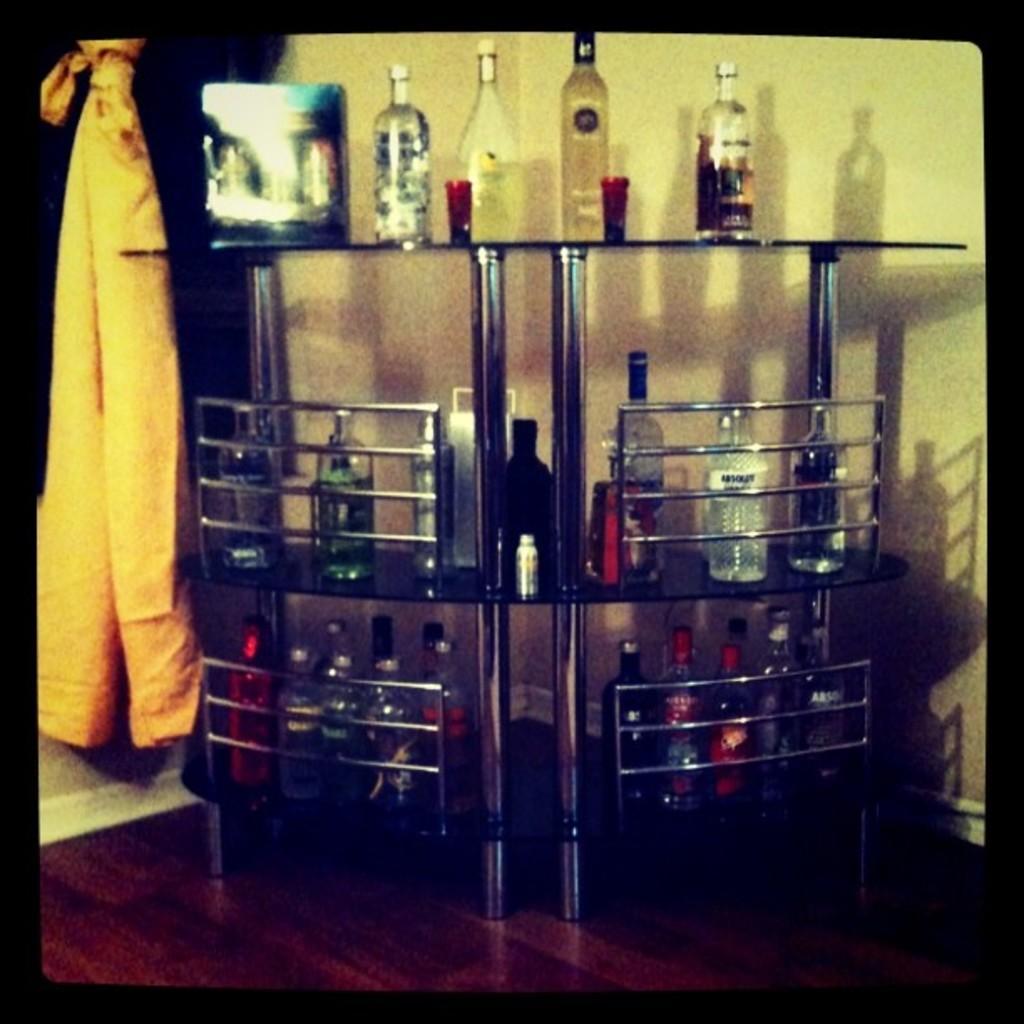Can you describe this image briefly? In this picture I can observe some wine bottles placed in the racks. On left side I can observe yellow color cloth. In the background there is a wall. 